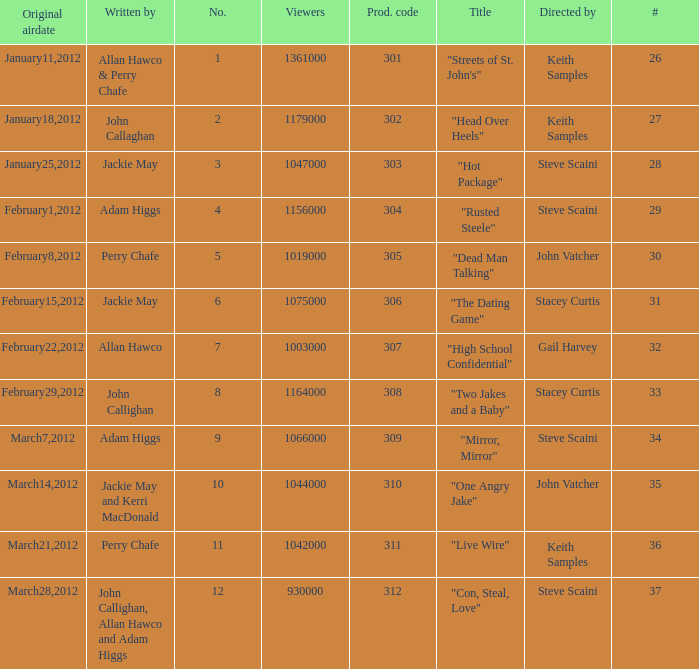What is the total number of films directy and written by john callaghan? 1.0. 